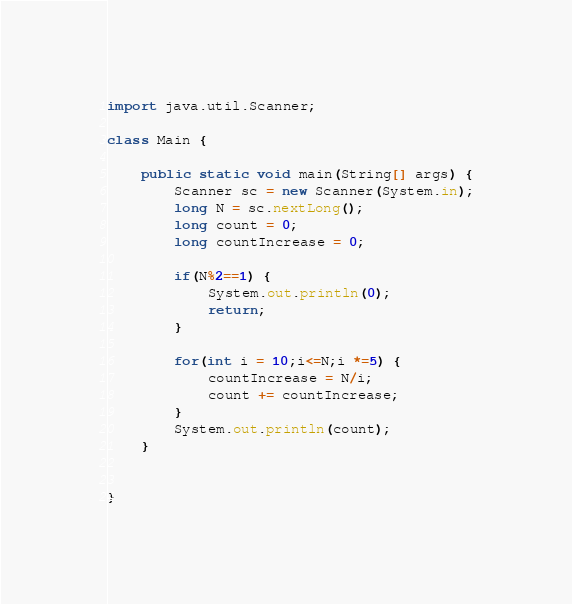<code> <loc_0><loc_0><loc_500><loc_500><_Java_>
import java.util.Scanner;

class Main {

	public static void main(String[] args) {
		Scanner sc = new Scanner(System.in);
		long N = sc.nextLong();
		long count = 0;
		long countIncrease = 0;
		
		if(N%2==1) {
			System.out.println(0);
			return;
		}

		for(int i = 10;i<=N;i *=5) {
			countIncrease = N/i;
			count += countIncrease;
		}
		System.out.println(count);
	}
		

}




</code> 